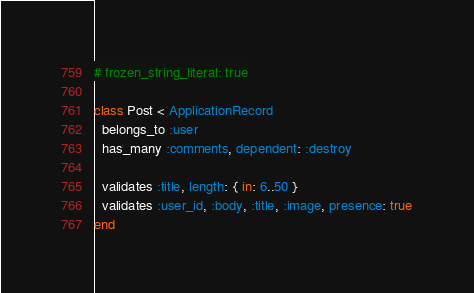Convert code to text. <code><loc_0><loc_0><loc_500><loc_500><_Ruby_># frozen_string_literal: true

class Post < ApplicationRecord
  belongs_to :user
  has_many :comments, dependent: :destroy

  validates :title, length: { in: 6..50 }
  validates :user_id, :body, :title, :image, presence: true
end
</code> 